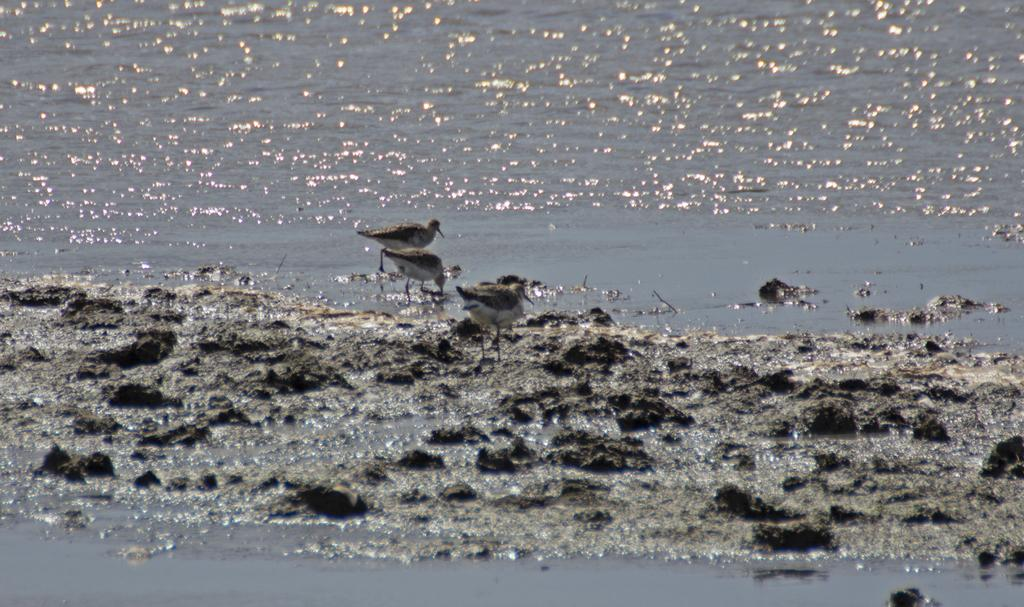What animals can be seen in the image? There are birds in the mud in the image. What else can be seen in the image besides the birds? There is water visible in the image. What type of nose can be seen on the birds in the image? Birds do not have noses like humans; they have a beak for their respiratory and feeding functions. In the image, the birds have beaks, not noses. Are the birds in the image feeling hot? The image does not provide any information about the temperature or the feelings of the birds, so it cannot be determined from the image. 